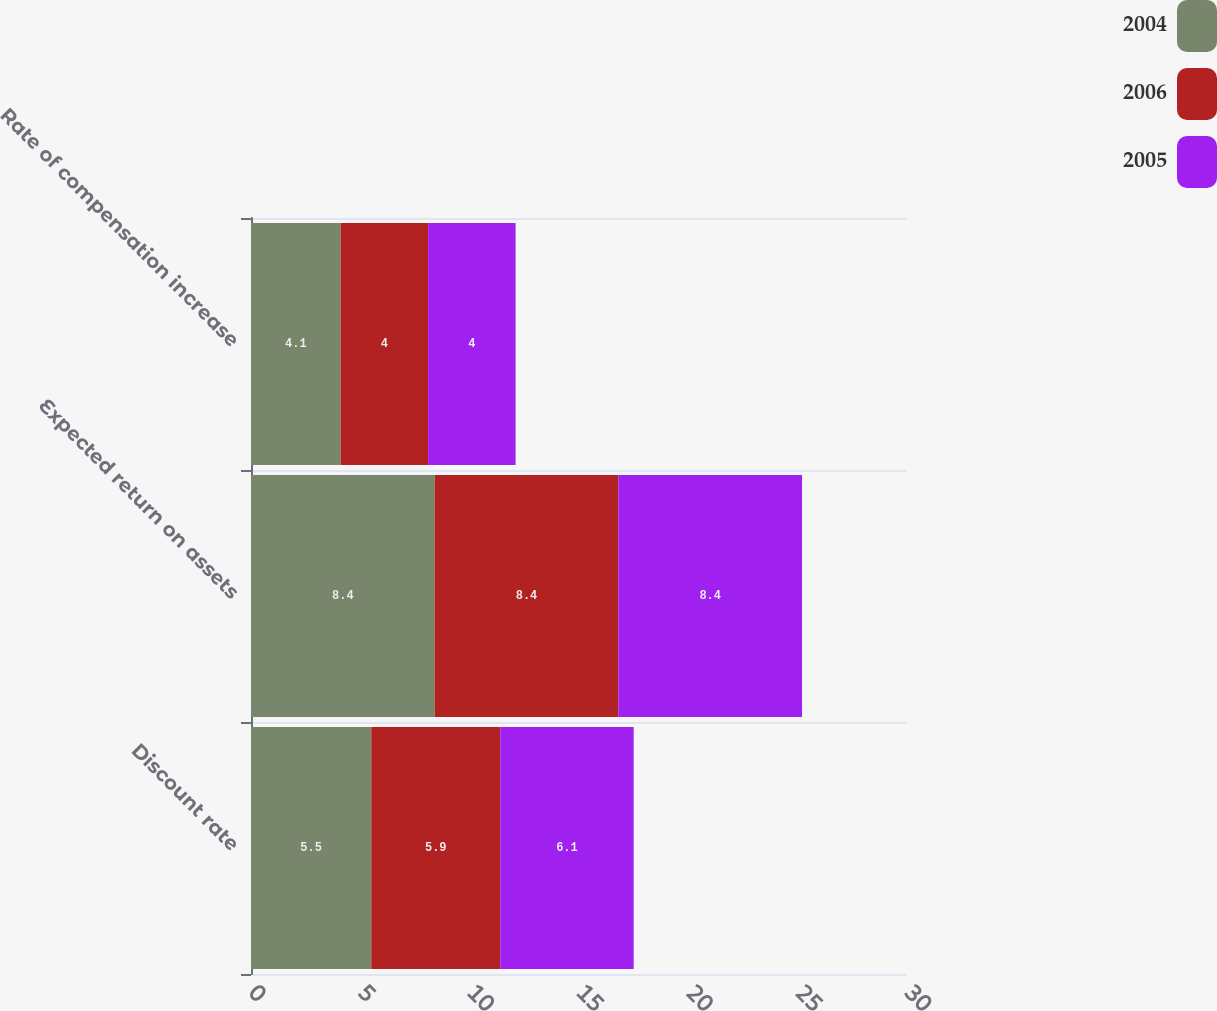Convert chart. <chart><loc_0><loc_0><loc_500><loc_500><stacked_bar_chart><ecel><fcel>Discount rate<fcel>Expected return on assets<fcel>Rate of compensation increase<nl><fcel>2004<fcel>5.5<fcel>8.4<fcel>4.1<nl><fcel>2006<fcel>5.9<fcel>8.4<fcel>4<nl><fcel>2005<fcel>6.1<fcel>8.4<fcel>4<nl></chart> 